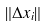Convert formula to latex. <formula><loc_0><loc_0><loc_500><loc_500>\| \Delta x _ { i } \|</formula> 